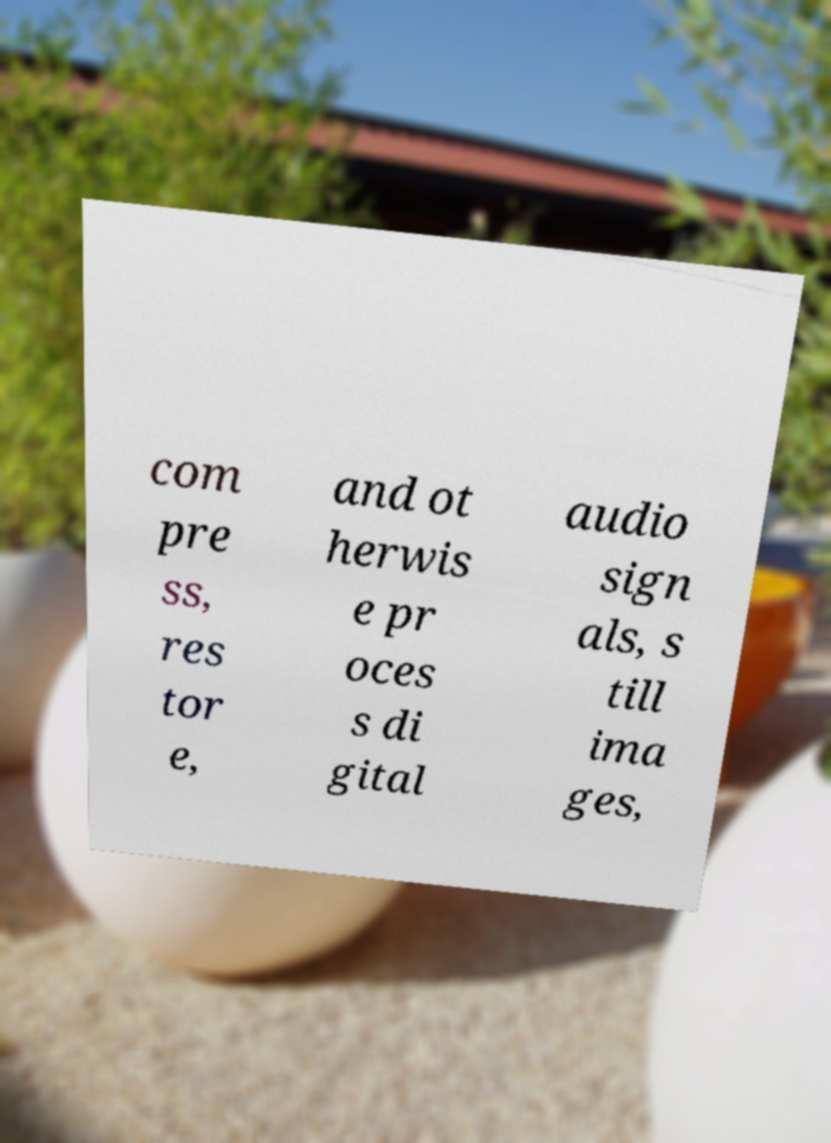Could you extract and type out the text from this image? com pre ss, res tor e, and ot herwis e pr oces s di gital audio sign als, s till ima ges, 